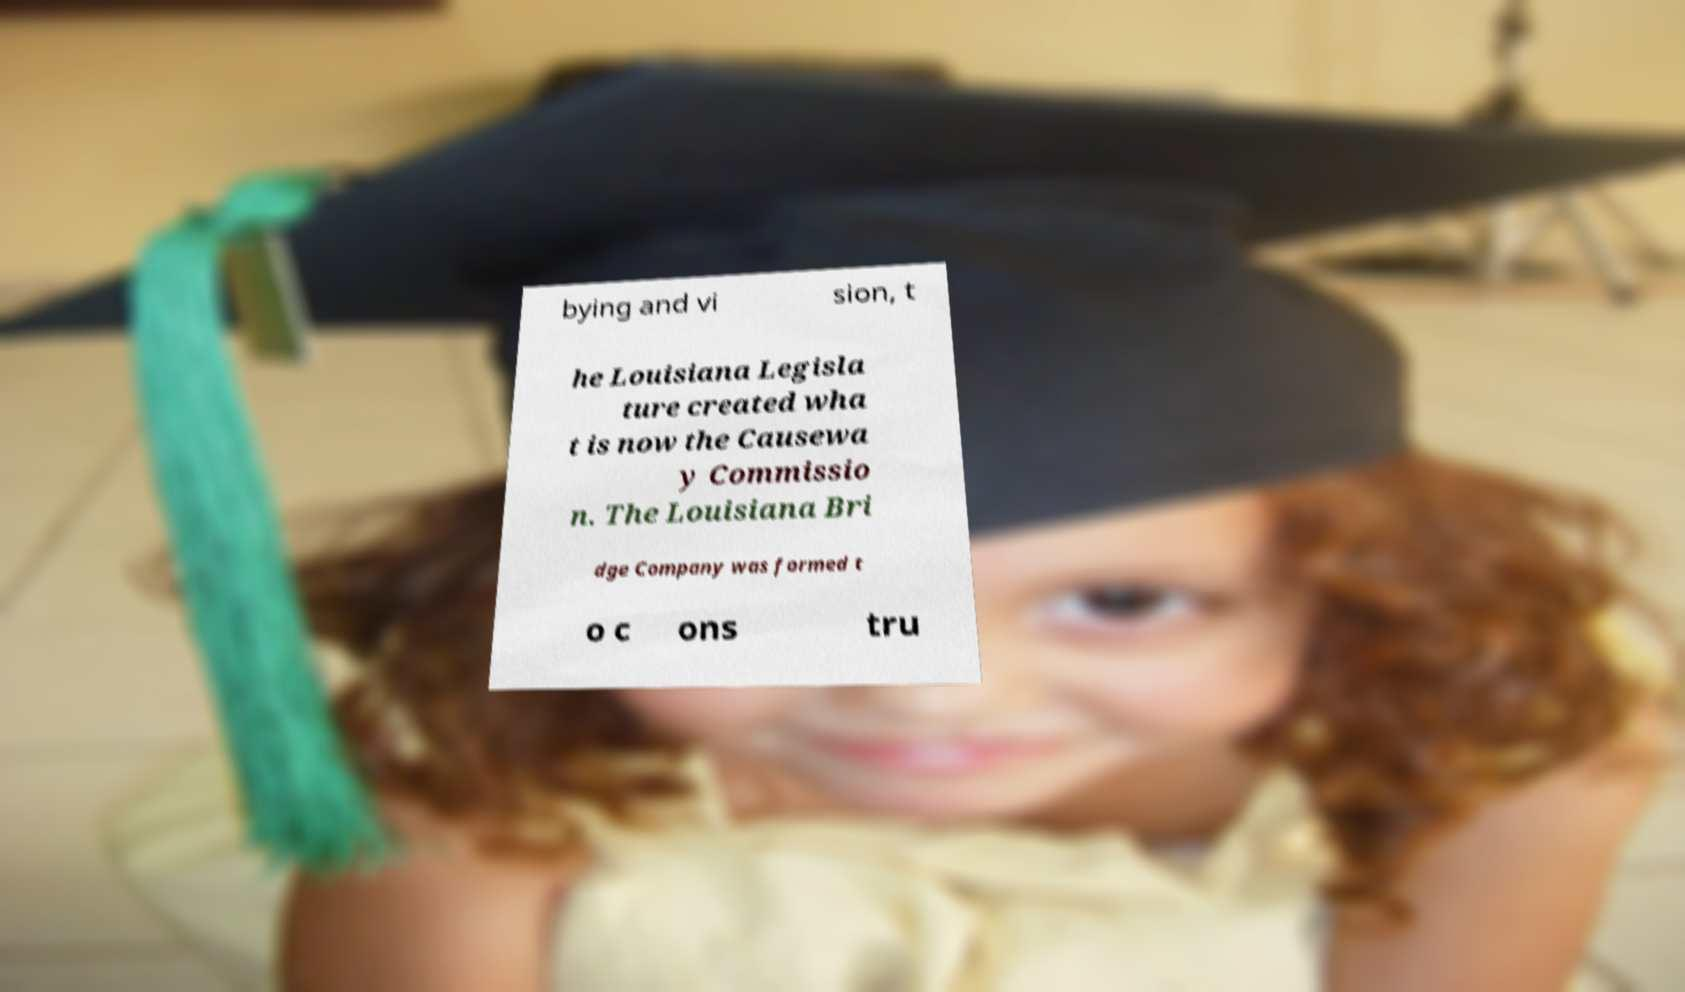Please identify and transcribe the text found in this image. bying and vi sion, t he Louisiana Legisla ture created wha t is now the Causewa y Commissio n. The Louisiana Bri dge Company was formed t o c ons tru 